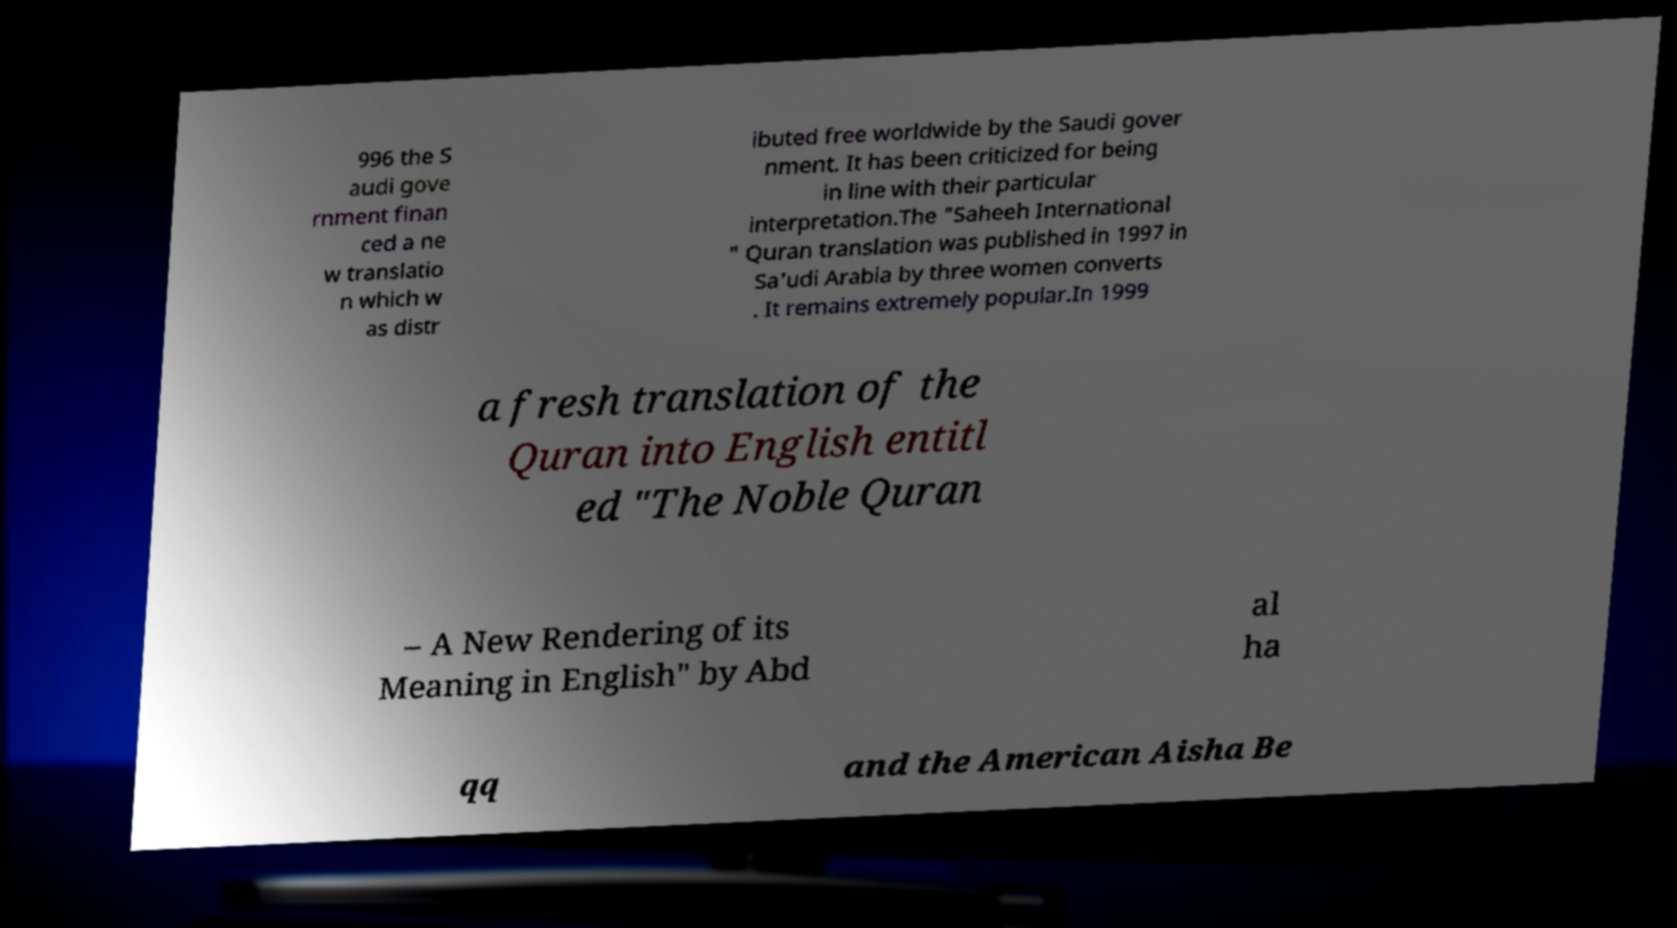I need the written content from this picture converted into text. Can you do that? 996 the S audi gove rnment finan ced a ne w translatio n which w as distr ibuted free worldwide by the Saudi gover nment. It has been criticized for being in line with their particular interpretation.The "Saheeh International " Quran translation was published in 1997 in Sa'udi Arabia by three women converts . It remains extremely popular.In 1999 a fresh translation of the Quran into English entitl ed "The Noble Quran – A New Rendering of its Meaning in English" by Abd al ha qq and the American Aisha Be 